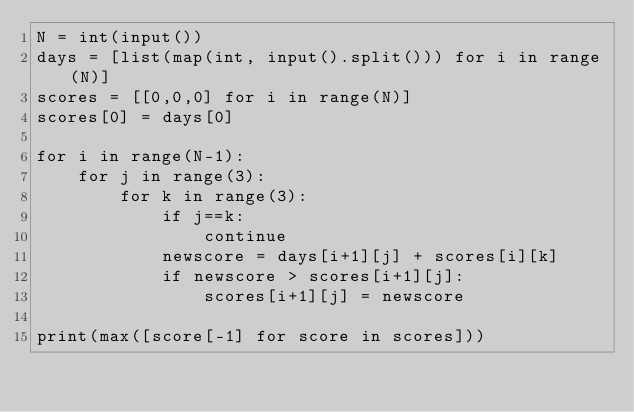<code> <loc_0><loc_0><loc_500><loc_500><_Python_>N = int(input())
days = [list(map(int, input().split())) for i in range(N)]
scores = [[0,0,0] for i in range(N)]
scores[0] = days[0]

for i in range(N-1):
    for j in range(3):
        for k in range(3):
            if j==k:
                continue
            newscore = days[i+1][j] + scores[i][k]
            if newscore > scores[i+1][j]:
                scores[i+1][j] = newscore

print(max([score[-1] for score in scores]))</code> 